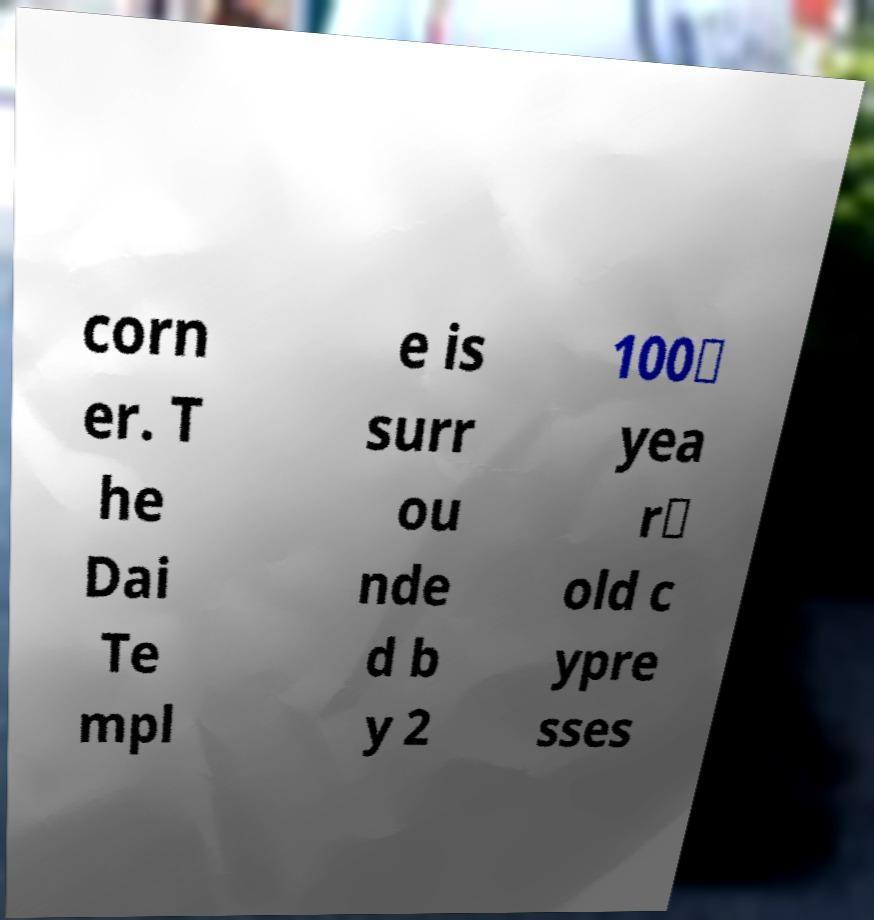Could you extract and type out the text from this image? corn er. T he Dai Te mpl e is surr ou nde d b y 2 100‑ yea r‑ old c ypre sses 